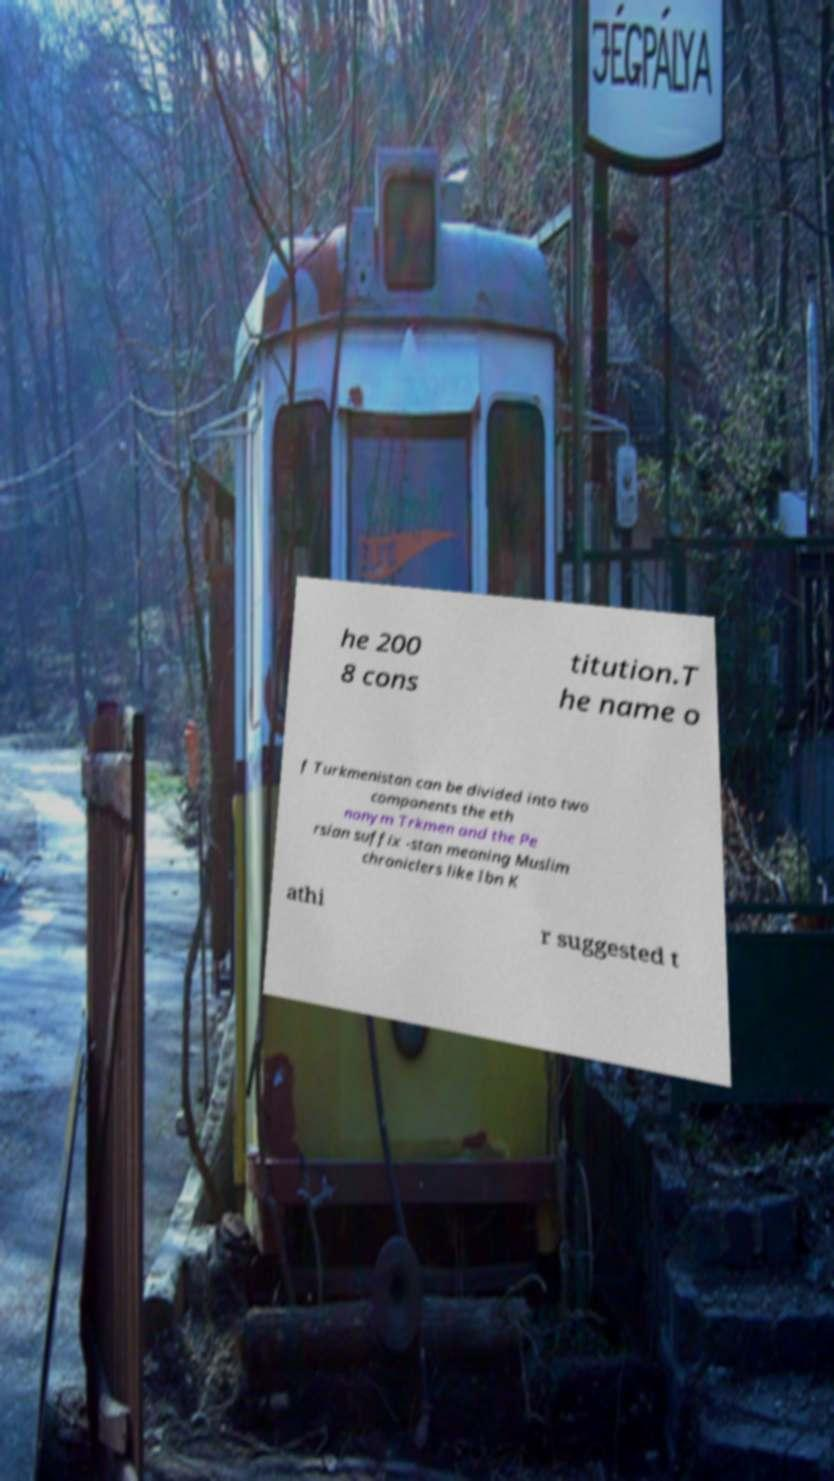Could you assist in decoding the text presented in this image and type it out clearly? he 200 8 cons titution.T he name o f Turkmenistan can be divided into two components the eth nonym Trkmen and the Pe rsian suffix -stan meaning Muslim chroniclers like Ibn K athi r suggested t 